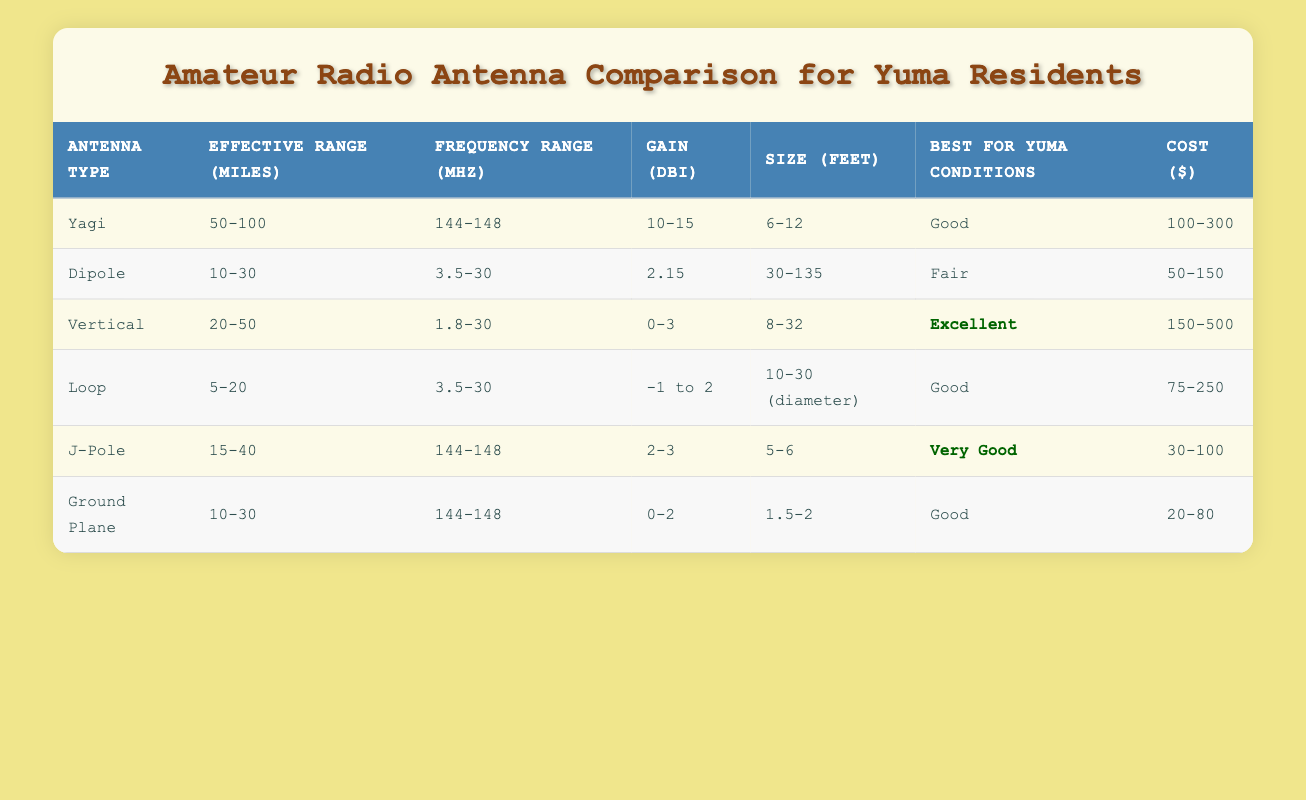What is the effective range of a Yagi antenna? The table specifically lists the effective range of a Yagi antenna as "50-100 miles."
Answer: 50-100 miles Which antenna type has the highest gain? By examining the gain values in the table, the Yagi antenna has the highest gain listed at "10-15 dBi."
Answer: Yagi Is the J-Pole antenna effective for a range of at least 30 miles? The effective range for the J-Pole antenna is stated as "15-40 miles," indicating it does not consistently reach 30 miles, as the minimum is below 30.
Answer: No What is the average size of a Dipole antenna? The size of a Dipole antenna is listed as "30-135 feet." To find the average, take the midpoint: (30 + 135) / 2 = 82.5 feet.
Answer: 82.5 feet Which antenna type is deemed "Excellent" for Yuma conditions? According to the table, the Vertical antenna is marked as "Excellent" for Yuma conditions.
Answer: Vertical Which antenna has the lowest cost range? The Ground Plane antenna shows the lowest cost range of "20-80 dollars" compared to other antennas listed.
Answer: 20-80 dollars If I want to use an antenna with a frequency range above 100 MHz, which type should I choose? The Yagi and J-Pole antennas have frequency ranges starting at 144 MHz, which is above 100 MHz; thus, either would suffice.
Answer: Yagi, J-Pole What is the total effective range of all antenna types? By summing the average effective ranges calculated as follows: Yagi (75) + Dipole (20) + Vertical (35) + Loop (12.5) + J-Pole (27.5) + Ground Plane (20) gives a total of 190 miles.
Answer: 190 miles Does the Loop antenna have a gain less than 0 dBi? The Loop antenna's gain is noted as "-1 to 2 dBi," which indeed means it can be less than 0 dBi.
Answer: Yes What are the two antennas with a "Good" rating for Yuma conditions? On the table, both the Yagi and Ground Plane antennas are rated as "Good" for Yuma conditions.
Answer: Yagi, Ground Plane 